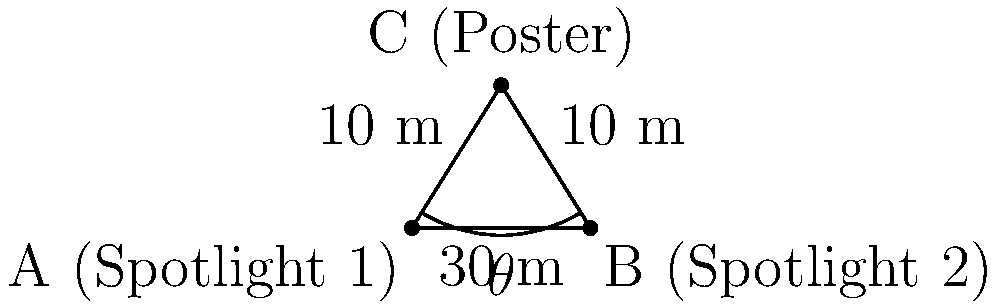At the premiere of Elena Tsavalia's latest film, two spotlights are illuminating a movie poster. Spotlight 1 is positioned 10 meters to the left of the poster, and Spotlight 2 is positioned 10 meters to the right of the poster. The distance between the two spotlights is 30 meters. What is the angle $\theta$ (in degrees) between the two spotlights from the poster's perspective? Let's approach this step-by-step:

1) We can see that this forms an isosceles triangle, with the poster at the apex and the spotlights at the base.

2) Let's call the angle we're looking for $\theta$. Since the triangle is isosceles, the base angles are equal. Let's call each of these base angles $\alpha$.

3) We know that the angles in a triangle sum to 180°, so:

   $\theta + \alpha + \alpha = 180°$
   $\theta + 2\alpha = 180°$

4) Now, we can use the cosine law to find $\cos(\alpha)$:

   $\cos(\alpha) = \frac{10^2 + 10^2 - 30^2}{2(10)(10)} = \frac{200 - 900}{200} = -\frac{7}{2}$

5) We can find $\alpha$ using the inverse cosine function:

   $\alpha = \arccos(-\frac{7}{2}) \approx 151.04°$

6) Now we can solve for $\theta$:

   $\theta = 180° - 2\alpha = 180° - 2(151.04°) = -122.08°$

7) Since we're looking for the positive angle, we take the absolute value:

   $\theta = 122.08°$

8) Rounding to the nearest degree:

   $\theta \approx 122°$
Answer: $122°$ 